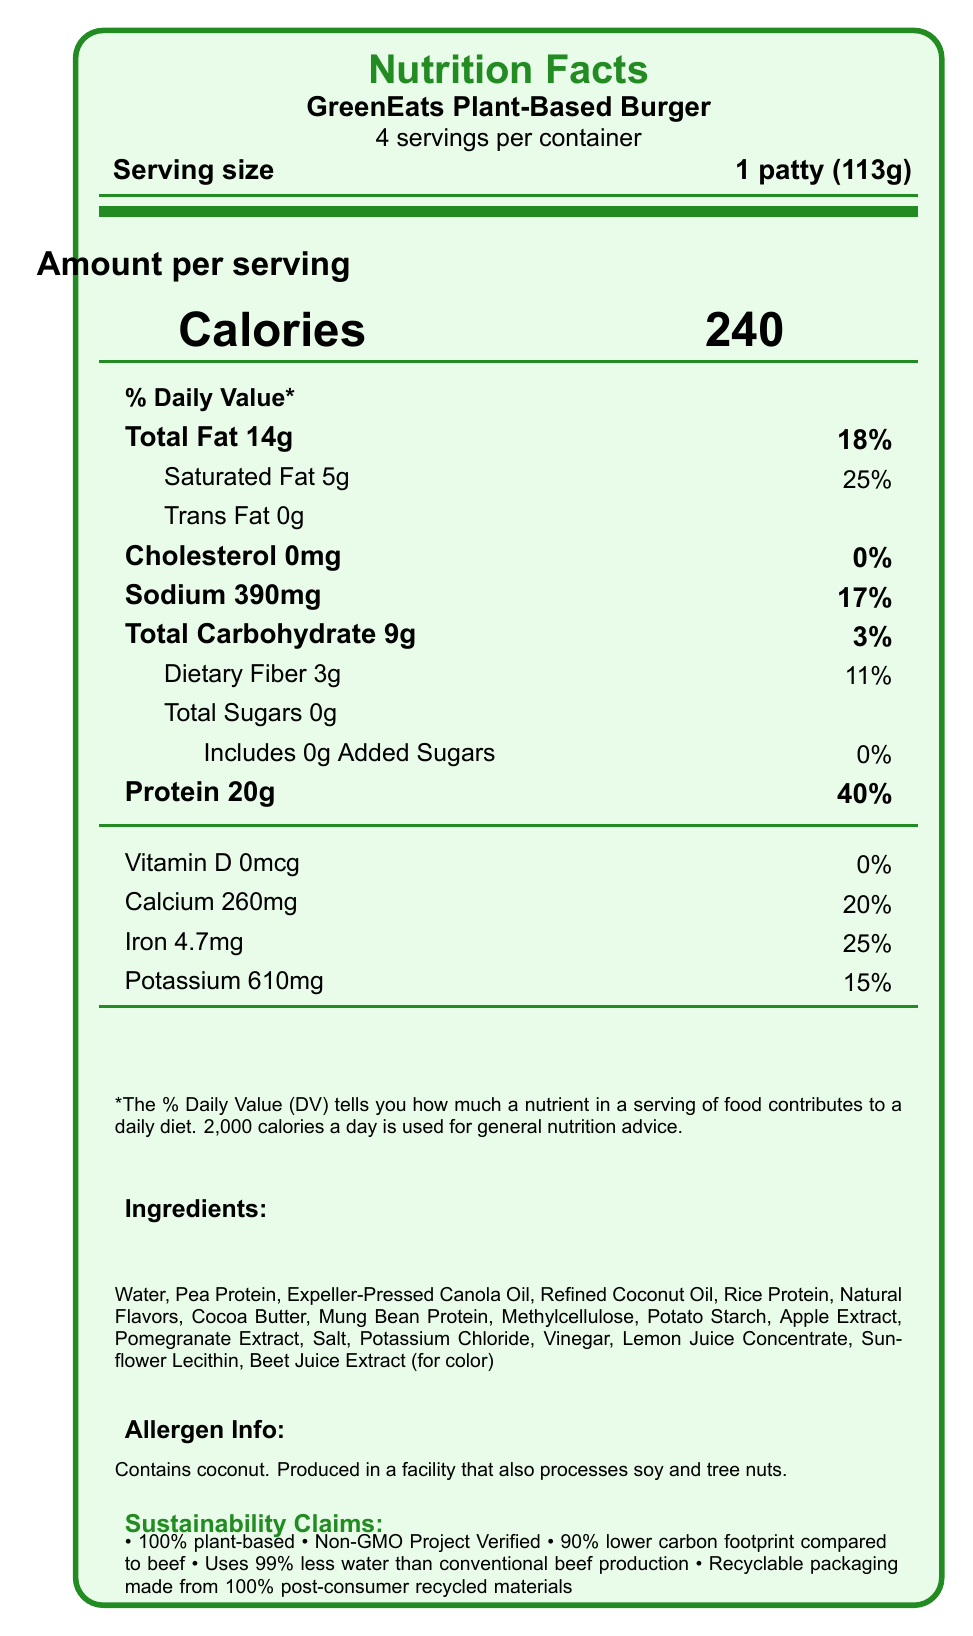How many servings are in a container of GreenEats Plant-Based Burger? It is mentioned in the document that there are 4 servings per container.
Answer: 4 What is the serving size of the GreenEats Plant-Based Burger? The serving size is stated as 1 patty (113g).
Answer: 1 patty (113g) How many calories are there in one serving? The document specifies that 1 serving contains 240 calories.
Answer: 240 What is the total fat content per serving? The total fat content per serving is listed as 14g.
Answer: 14g How much protein does each serving provide? The protein content per serving is given as 20g.
Answer: 20g What percentage of daily value does the calcium content per serving constitute? The document states that each serving provides 20% of the daily value for calcium.
Answer: 20% Does the GreenEats Plant-Based Burger contain any trans fat? The document indicates that the trans fat content is 0g per serving.
Answer: No What are the main sources of protein in the ingredients list? The main sources of protein listed in the ingredients are Pea Protein, Rice Protein, and Mung Bean Protein.
Answer: Pea Protein, Rice Protein, Mung Bean Protein Which sustainability claim is made about the water usage of the product? A. 90% lower carbon footprint compared to beef B. Non-GMO Project Verified C. Uses 99% less water than conventional beef production D. Recyclable packaging made from 100% post-consumer recycled materials The product claims to use 99% less water than conventional beef production.
Answer: C Which of the following certifications does the GreenEats Plant-Based Burger have? I. Certified Vegan II. USDA Organic III. Kosher IV. Non-GMO Project Verified The document lists Certified Vegan, Kosher, and Non-GMO Project Verified as certifications, but not USDA Organic.
Answer: I, III, IV Does this product contain any ingredients that are allergens? The document specifies that it contains coconut and is produced in a facility that also processes soy and tree nuts.
Answer: Yes Is the GreenEats Plant-Based Burger cholesterol-free? The document shows that the cholesterol content is 0mg per serving.
Answer: Yes Summarize the main features and claims of the GreenEats Plant-Based Burger mentioned in the document. The document provides nutrition facts, ingredient details, allergen information, sustainability claims, and certifications about the product.
Answer: The GreenEats Plant-Based Burger offers a nutritious alternative to beef with each 113g patty providing 240 calories, 14g of total fat, 0mg of cholesterol, and 20g of protein. It is rich in essential nutrients like calcium and iron. The ingredients include pea protein, rice protein, and mung bean protein, among others. It is 100% plant-based, has a lower carbon footprint, uses significantly less water compared to beef, and comes in recyclable packaging. It is certified vegan, kosher, and Non-GMO Project Verified. How much added sugar is in each serving of the GreenEats Plant-Based Burger? It is stated that each serving includes 0g of added sugars.
Answer: 0g Can you determine the exact manufacturing process of the GreenEats Plant-Based Burger from the document? The document does not provide any details about the manufacturing process of the product.
Answer: Cannot be determined 